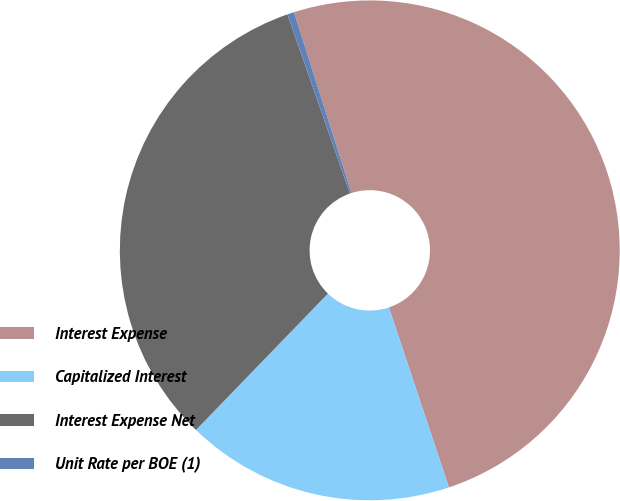Convert chart. <chart><loc_0><loc_0><loc_500><loc_500><pie_chart><fcel>Interest Expense<fcel>Capitalized Interest<fcel>Interest Expense Net<fcel>Unit Rate per BOE (1)<nl><fcel>49.78%<fcel>17.37%<fcel>32.42%<fcel>0.44%<nl></chart> 